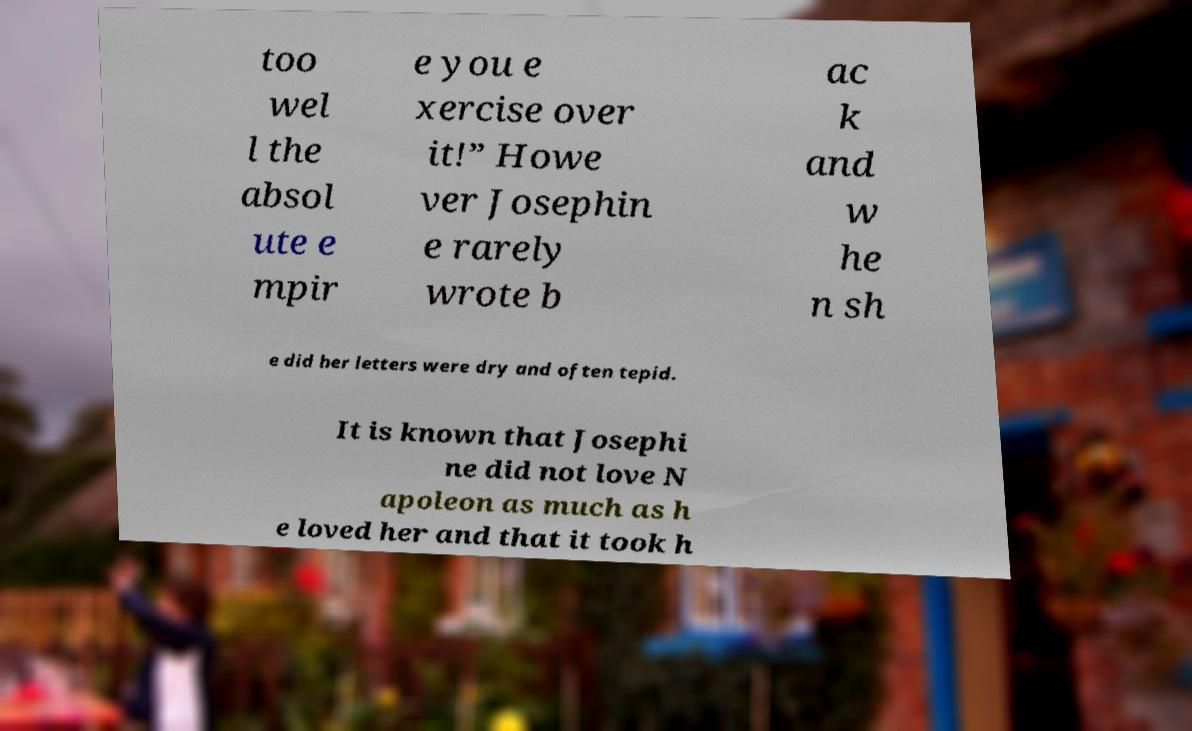Can you read and provide the text displayed in the image?This photo seems to have some interesting text. Can you extract and type it out for me? too wel l the absol ute e mpir e you e xercise over it!” Howe ver Josephin e rarely wrote b ac k and w he n sh e did her letters were dry and often tepid. It is known that Josephi ne did not love N apoleon as much as h e loved her and that it took h 